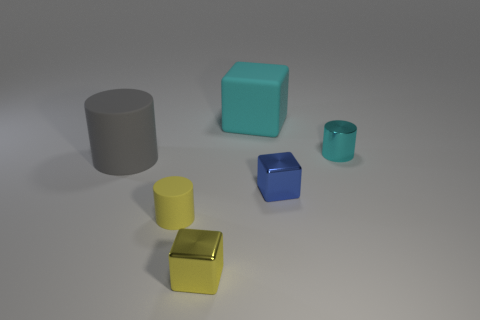Subtract all tiny blue cubes. How many cubes are left? 2 Add 4 yellow metal cylinders. How many objects exist? 10 Subtract 1 blocks. How many blocks are left? 2 Subtract all small green spheres. Subtract all gray rubber cylinders. How many objects are left? 5 Add 6 big cyan matte blocks. How many big cyan matte blocks are left? 7 Add 2 large gray rubber things. How many large gray rubber things exist? 3 Subtract 1 blue blocks. How many objects are left? 5 